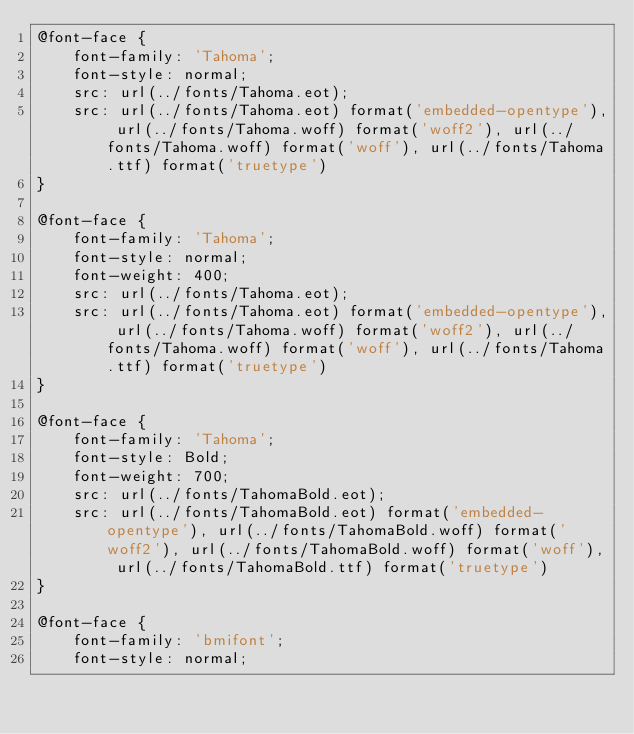Convert code to text. <code><loc_0><loc_0><loc_500><loc_500><_CSS_>@font-face {
    font-family: 'Tahoma';
    font-style: normal;
    src: url(../fonts/Tahoma.eot);
    src: url(../fonts/Tahoma.eot) format('embedded-opentype'), url(../fonts/Tahoma.woff) format('woff2'), url(../fonts/Tahoma.woff) format('woff'), url(../fonts/Tahoma.ttf) format('truetype')
}

@font-face {
    font-family: 'Tahoma';
    font-style: normal;
    font-weight: 400;
    src: url(../fonts/Tahoma.eot);
    src: url(../fonts/Tahoma.eot) format('embedded-opentype'), url(../fonts/Tahoma.woff) format('woff2'), url(../fonts/Tahoma.woff) format('woff'), url(../fonts/Tahoma.ttf) format('truetype')
}

@font-face {
    font-family: 'Tahoma';
    font-style: Bold;
    font-weight: 700;
    src: url(../fonts/TahomaBold.eot);
    src: url(../fonts/TahomaBold.eot) format('embedded-opentype'), url(../fonts/TahomaBold.woff) format('woff2'), url(../fonts/TahomaBold.woff) format('woff'), url(../fonts/TahomaBold.ttf) format('truetype')
}

@font-face {
    font-family: 'bmifont';
    font-style: normal;</code> 